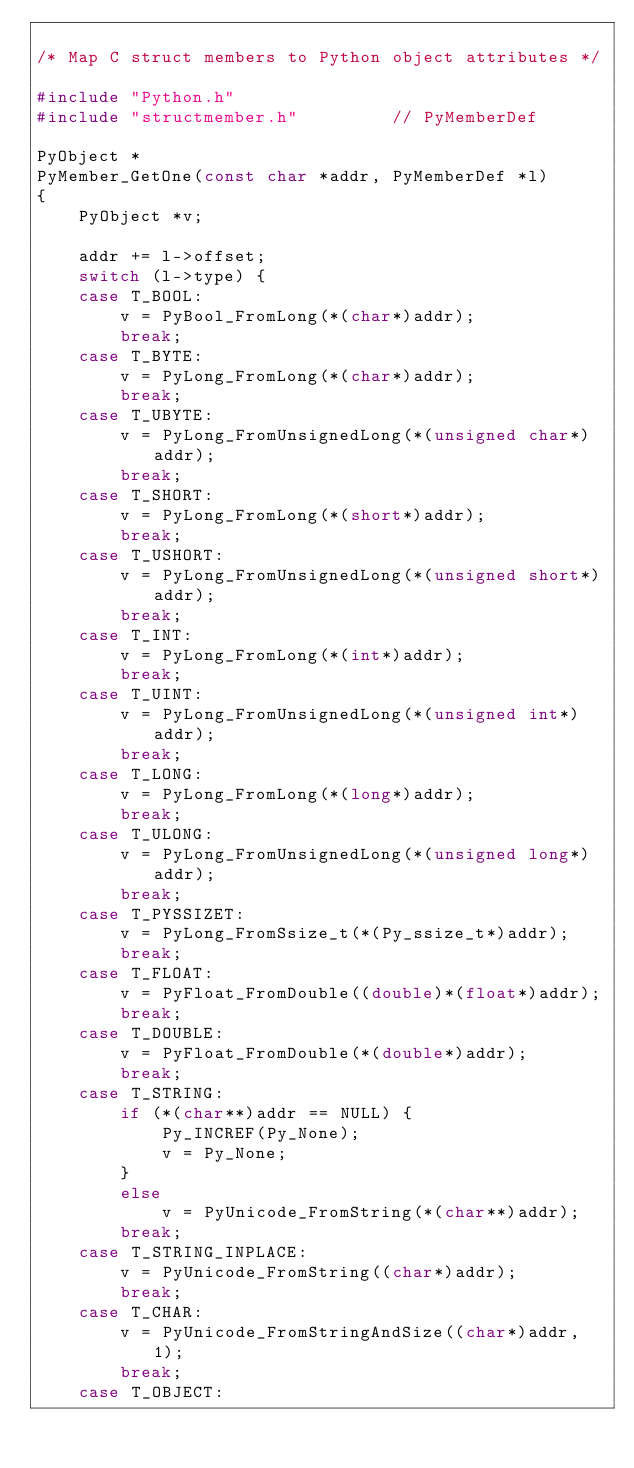Convert code to text. <code><loc_0><loc_0><loc_500><loc_500><_C_>
/* Map C struct members to Python object attributes */

#include "Python.h"
#include "structmember.h"         // PyMemberDef

PyObject *
PyMember_GetOne(const char *addr, PyMemberDef *l)
{
    PyObject *v;

    addr += l->offset;
    switch (l->type) {
    case T_BOOL:
        v = PyBool_FromLong(*(char*)addr);
        break;
    case T_BYTE:
        v = PyLong_FromLong(*(char*)addr);
        break;
    case T_UBYTE:
        v = PyLong_FromUnsignedLong(*(unsigned char*)addr);
        break;
    case T_SHORT:
        v = PyLong_FromLong(*(short*)addr);
        break;
    case T_USHORT:
        v = PyLong_FromUnsignedLong(*(unsigned short*)addr);
        break;
    case T_INT:
        v = PyLong_FromLong(*(int*)addr);
        break;
    case T_UINT:
        v = PyLong_FromUnsignedLong(*(unsigned int*)addr);
        break;
    case T_LONG:
        v = PyLong_FromLong(*(long*)addr);
        break;
    case T_ULONG:
        v = PyLong_FromUnsignedLong(*(unsigned long*)addr);
        break;
    case T_PYSSIZET:
        v = PyLong_FromSsize_t(*(Py_ssize_t*)addr);
        break;
    case T_FLOAT:
        v = PyFloat_FromDouble((double)*(float*)addr);
        break;
    case T_DOUBLE:
        v = PyFloat_FromDouble(*(double*)addr);
        break;
    case T_STRING:
        if (*(char**)addr == NULL) {
            Py_INCREF(Py_None);
            v = Py_None;
        }
        else
            v = PyUnicode_FromString(*(char**)addr);
        break;
    case T_STRING_INPLACE:
        v = PyUnicode_FromString((char*)addr);
        break;
    case T_CHAR:
        v = PyUnicode_FromStringAndSize((char*)addr, 1);
        break;
    case T_OBJECT:</code> 